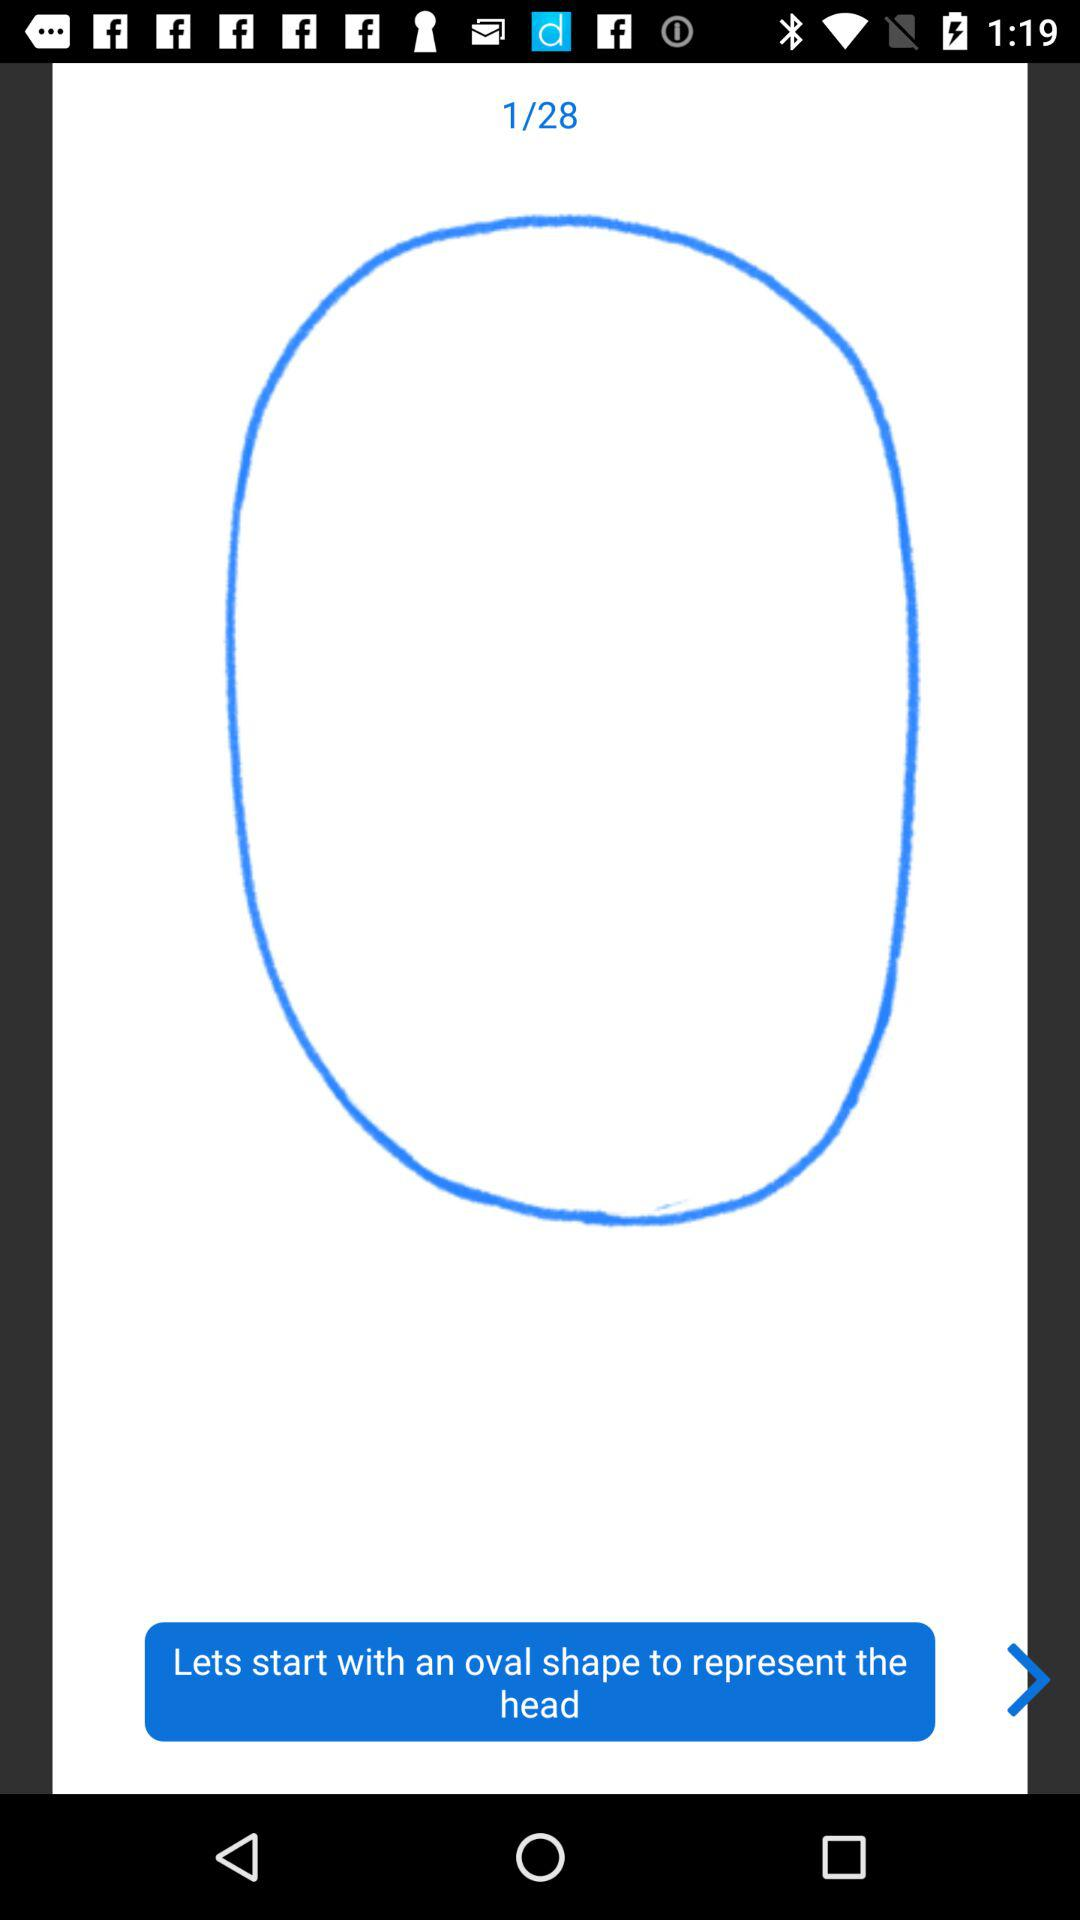What is the total number of pages? The total number of pages is 28. 